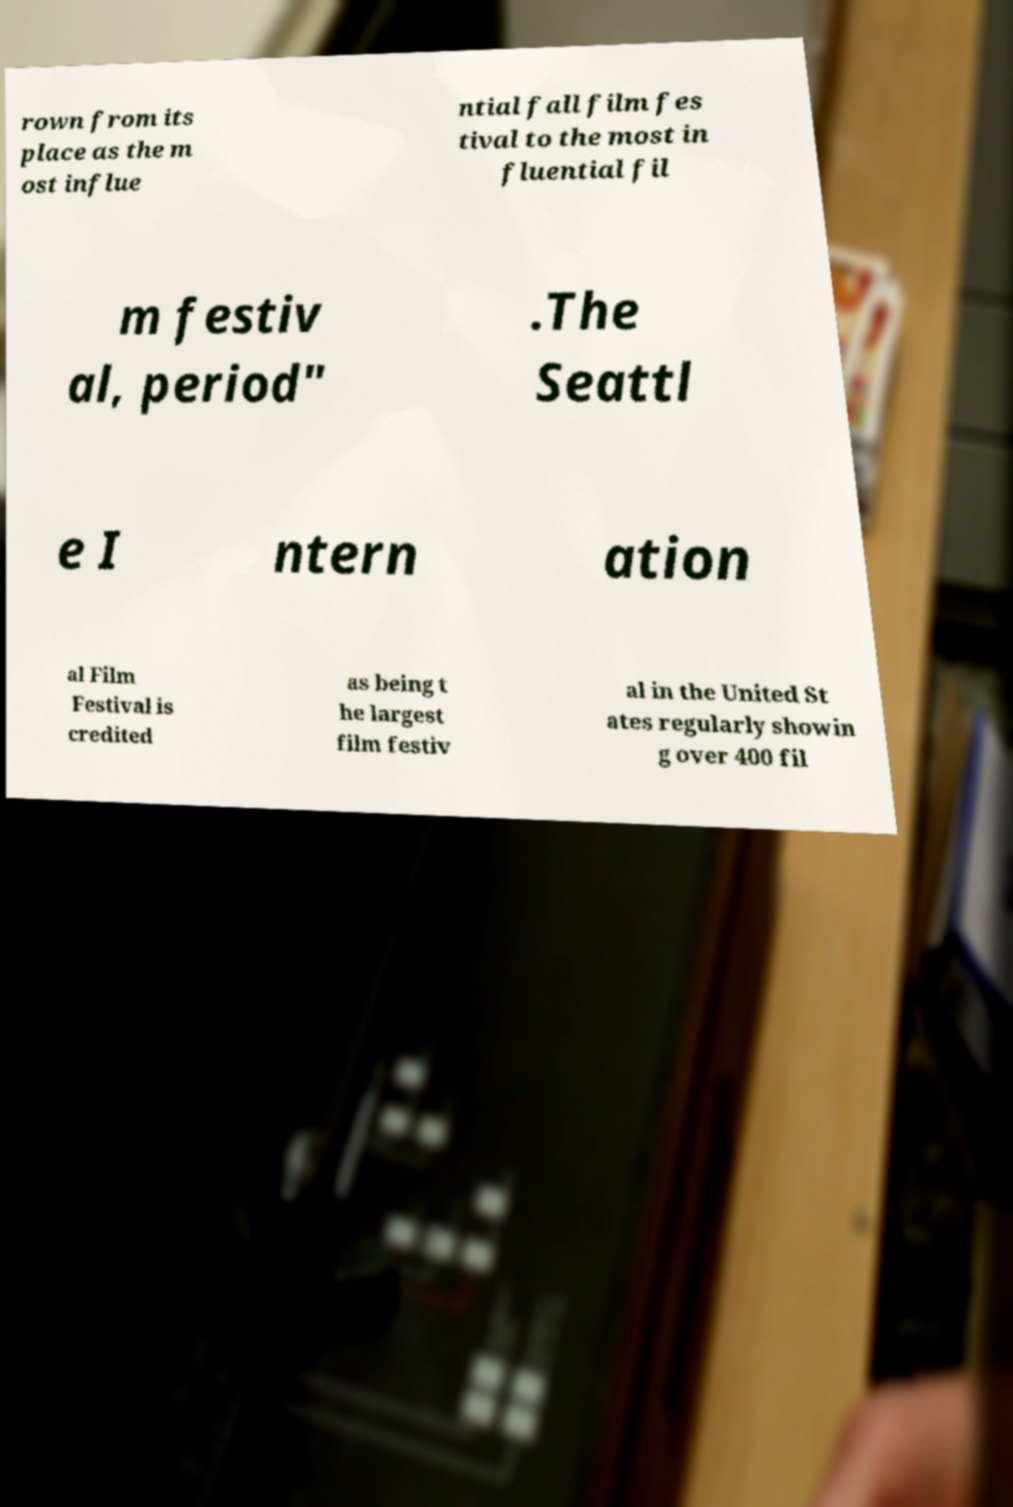Please identify and transcribe the text found in this image. rown from its place as the m ost influe ntial fall film fes tival to the most in fluential fil m festiv al, period" .The Seattl e I ntern ation al Film Festival is credited as being t he largest film festiv al in the United St ates regularly showin g over 400 fil 